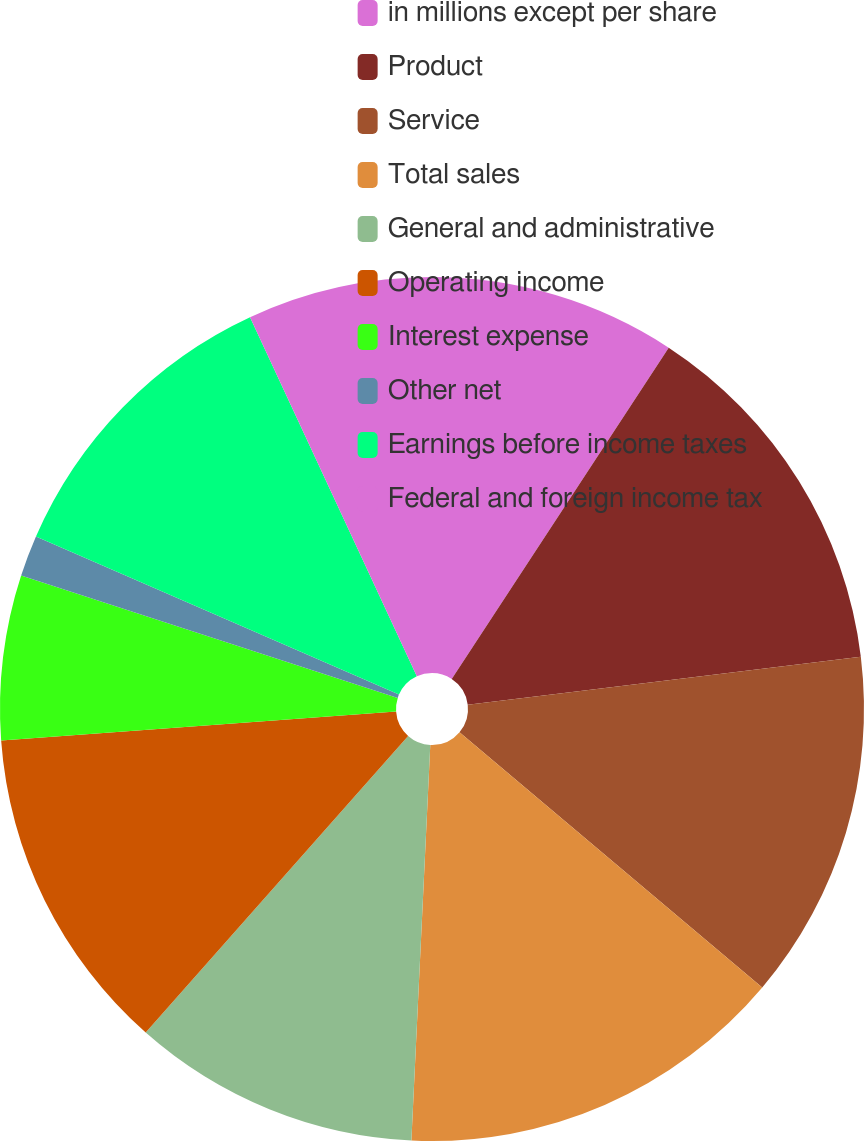<chart> <loc_0><loc_0><loc_500><loc_500><pie_chart><fcel>in millions except per share<fcel>Product<fcel>Service<fcel>Total sales<fcel>General and administrative<fcel>Operating income<fcel>Interest expense<fcel>Other net<fcel>Earnings before income taxes<fcel>Federal and foreign income tax<nl><fcel>9.23%<fcel>13.84%<fcel>13.08%<fcel>14.61%<fcel>10.77%<fcel>12.31%<fcel>6.16%<fcel>1.54%<fcel>11.54%<fcel>6.92%<nl></chart> 